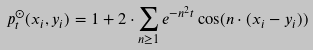<formula> <loc_0><loc_0><loc_500><loc_500>p _ { t } ^ { \odot } ( x _ { i } , y _ { i } ) = 1 + 2 \cdot \sum _ { n \geq 1 } e ^ { - n ^ { 2 } t } \cos ( n \cdot ( x _ { i } - y _ { i } ) )</formula> 